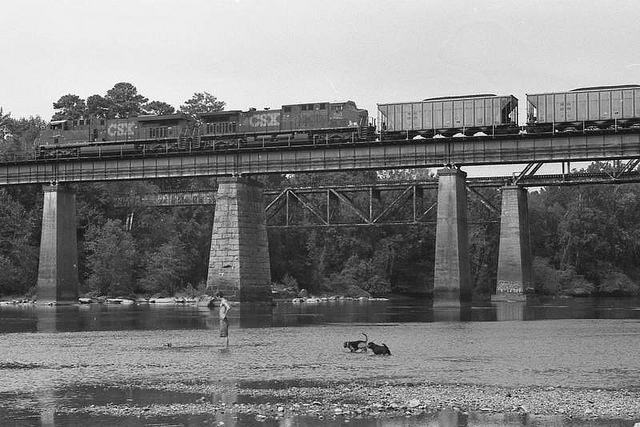Why is the train on a bridge? The train is on a bridge to safely cross the river beneath it. Bridges are essential structures allowing for the uninterrupted passage over obstacles like rivers, ensuring both the train’s journey and the river's natural flow are undisturbed. 